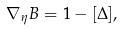Convert formula to latex. <formula><loc_0><loc_0><loc_500><loc_500>\nabla _ { \eta } B = 1 - [ \Delta ] ,</formula> 